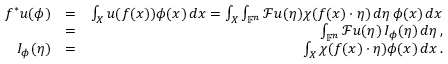<formula> <loc_0><loc_0><loc_500><loc_500>\begin{array} { r l r } { f ^ { * } u ( \phi ) } & { = } & { \int _ { X } u ( f ( x ) ) \phi ( x ) \, d x = \int _ { X } \int _ { \mathbb { F } ^ { n } } \mathcal { F } u ( \eta ) \chi ( f ( x ) \cdot \eta ) \, d \eta \, \phi ( x ) \, d x } \\ & { = } & { \int _ { \mathbb { F } ^ { n } } \mathcal { F } u ( \eta ) \, I _ { \phi } ( \eta ) \, d \eta \, , } \\ { I _ { \phi } ( \eta ) } & { = } & { \int _ { X } \chi ( f ( x ) \cdot \eta ) \phi ( x ) \, d x \, . } \end{array}</formula> 